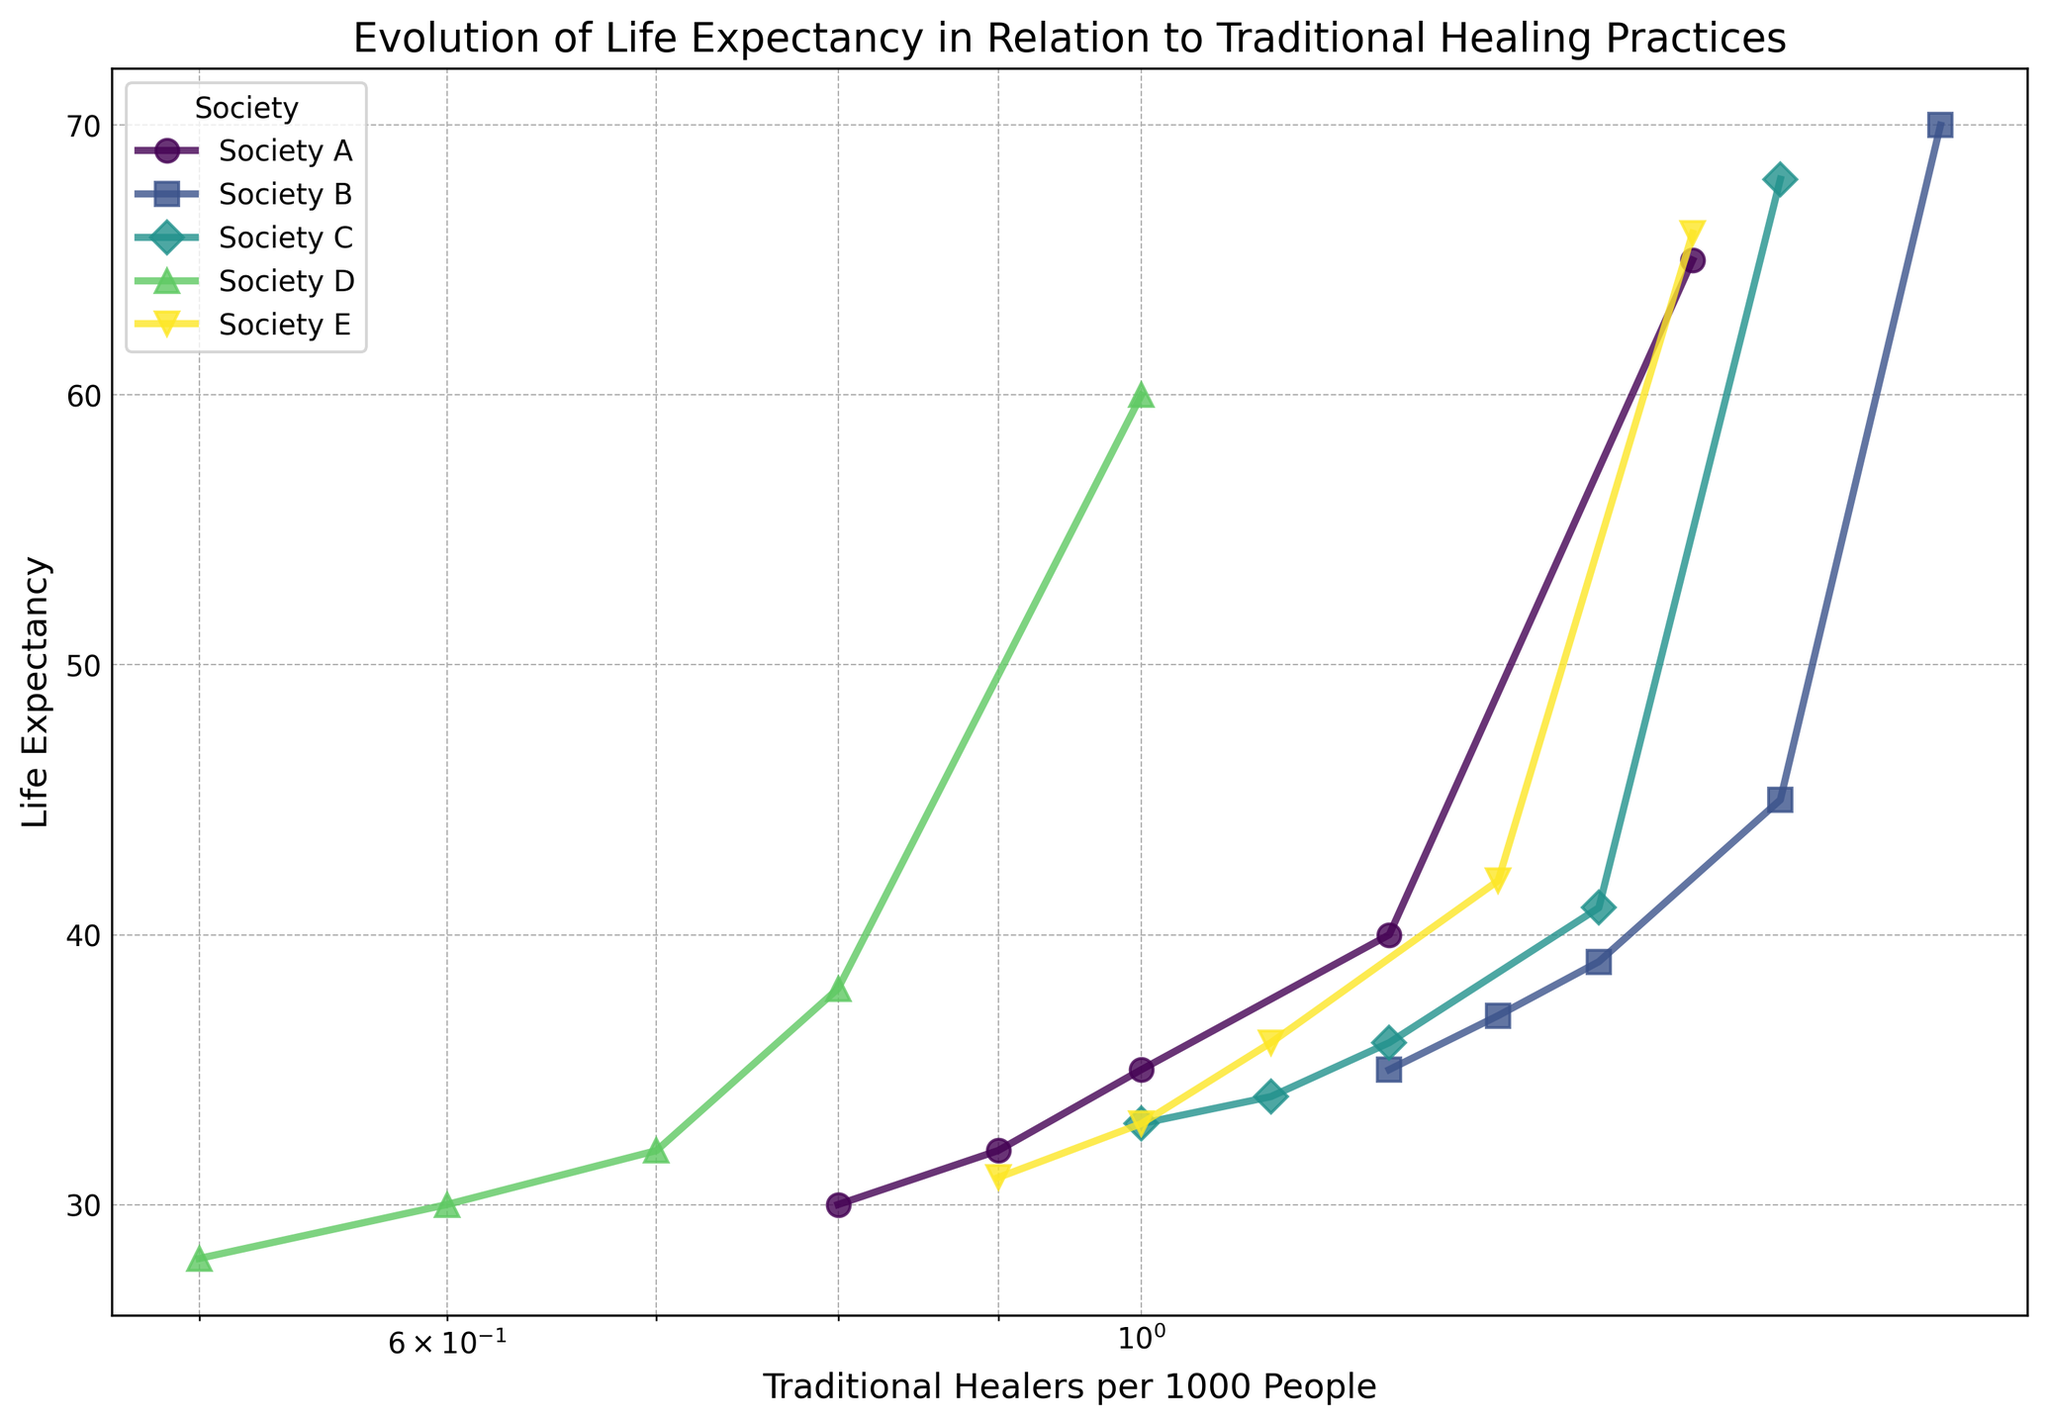What trend is observed in Society B from 1800 to 2000 regarding the number of traditional healers and life expectancy? Looking at the line for Society B, the plot shows an increasing trend in both the number of traditional healers per 1000 people and life expectancy over the years. Specifically, traditional healers increased from 1.2 to 1.8 per 1000 people, and life expectancy rose from 35 to 70 years.
Answer: Both values increase How does the number of traditional healers per 1000 people in Society A in 1850 compare to that in Society E in 2000? According to the figure, Society A had 0.9 traditional healers per 1000 people in 1850, while Society E had 1.5 in 2000. Therefore, Society E had more traditional healers per 1000 people in 2000 compared to Society A in 1850.
Answer: Society E had more Which society showed the largest increase in life expectancy from 1850 to 2000? By comparing the starting and ending points for each society's lines on the plot, Society B's life expectancy increased from 37 to 70, which is an increase of 33 years. This is the largest increase among all societies shown.
Answer: Society B Is there a direct correlation between the number of traditional healers per 1000 people and life expectancy for all societies? Observing the lines for each society, there appears to be a positive correlation overall; as the number of traditional healers per 1000 people increases, life expectancy also tends to increase.
Answer: Yes, a positive correlation Which society had the lowest number of traditional healers per 1000 people in 2000 and what was its life expectancy? The lowest number of traditional healers per 1000 people in 2000 is seen in Society D, which had 1.0 traditional healers per 1000 people and a life expectancy of 60 years.
Answer: Society D; 60 years Among Societies A, C, and D in the year 2000, which one showed the highest life expectancy? In the year 2000, looking at the endpoint of the lines for Societies A, C, and D, Society C showed the highest life expectancy at 68 years, compared to 65 years for Society A and 60 years for Society D.
Answer: Society C What is the average life expectancy across all societies in the year 1800? From the plot, we sum the life expectancy values for each society in 1800: (30 + 35 + 33 + 28 + 31) and then divide by the number of societies, which is 5. (30 + 35 + 33 + 28 + 31) / 5 = 31.4.
Answer: 31.4 Based on the visual plot, which society shows the most consistent increase in life expectancy over the years? By examining the smoothness and steadiness of the lines, Society C appears to show the most consistent (gradual and steady) increase in life expectancy from 1800 to 2000.
Answer: Society C For Society A, calculate the difference in life expectancy between 1800 and 2000. The life expectancy in Society A in 1800 was 30 years, and in 2000 it was 65 years. The difference is 65 - 30 = 35 years.
Answer: 35 years 